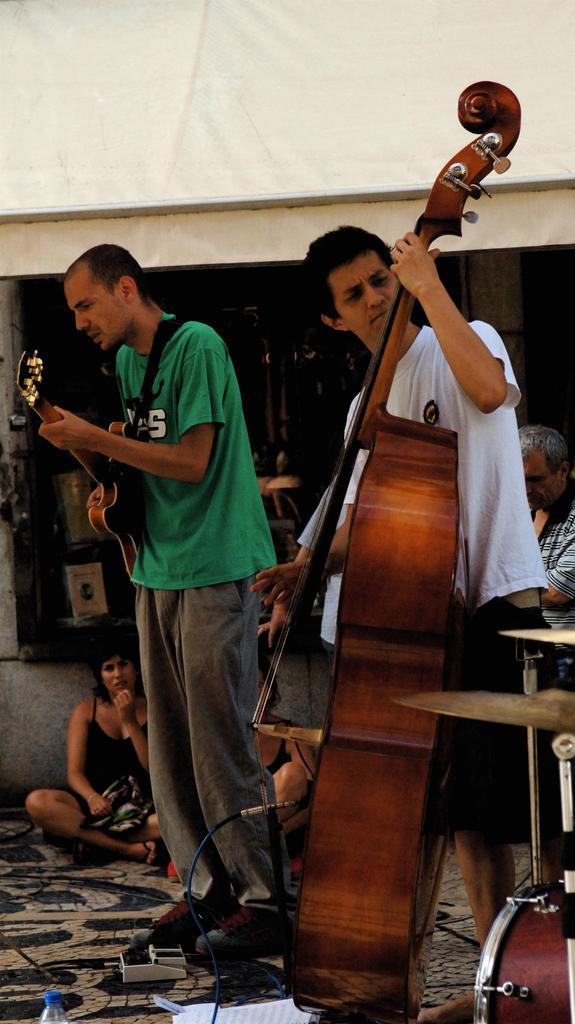How would you summarize this image in a sentence or two? In this picture there are two persons standing and playing guitars. On the left side of the image there are two persons sitting on the floor. At the back there are objects. On the right side of the image there is a person. In the foreground there is a drum. At the bottom there is a device, bottle and there are papers. 